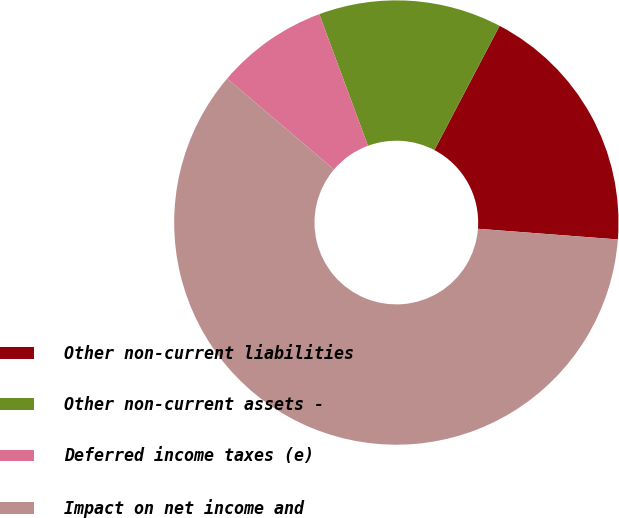Convert chart to OTSL. <chart><loc_0><loc_0><loc_500><loc_500><pie_chart><fcel>Other non-current liabilities<fcel>Other non-current assets -<fcel>Deferred income taxes (e)<fcel>Impact on net income and<nl><fcel>18.52%<fcel>13.33%<fcel>8.14%<fcel>60.01%<nl></chart> 